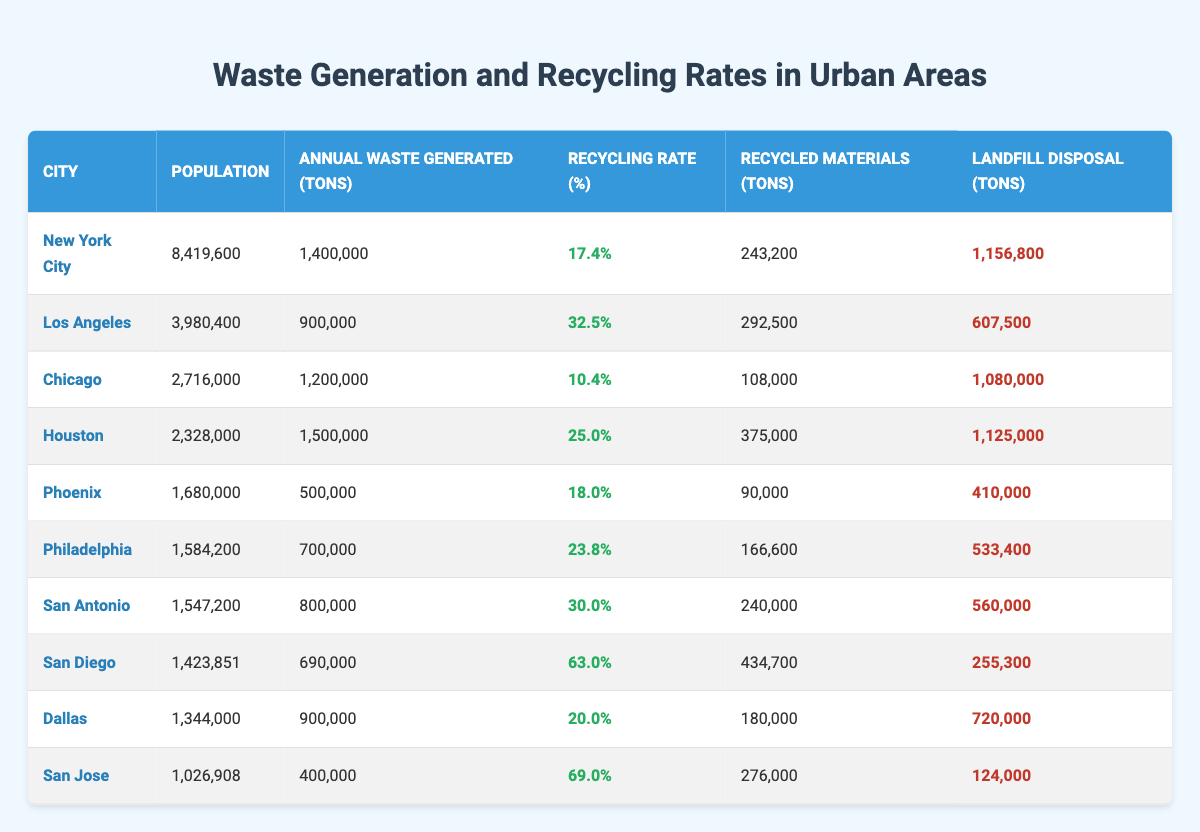What is the recycling rate percentage for Los Angeles? In the table, locate the row for Los Angeles and find the corresponding value under the "Recycling Rate (%)" column. The value is 32.5%.
Answer: 32.5% Which city generated the most annual waste in tons? Reviewing the "Annual Waste Generated (tons)" column, identify the maximum value, which corresponds to New York City with 1,400,000 tons.
Answer: New York City What is the landfill disposal amount for San Diego? Locate the row for San Diego and read the value in the "Landfill Disposal (tons)" column, which is 255,300 tons.
Answer: 255,300 tons What is the average recycling rate percentage of the cities listed? To find the average, sum the recycling rates: 17.4 + 32.5 + 10.4 + 25.0 + 18.0 + 23.8 + 30 + 63 + 20 + 69 =  289.1, then divide by the number of cities (10): 289.1 / 10 = 28.91%.
Answer: 28.91% Which city has the lowest recycling rate? Look through the "Recycling Rate (%)" column to find the minimum value, which is 10.4% from Chicago.
Answer: Chicago What is the total annual waste generated by the cities combined? Sum the values in the "Annual Waste Generated (tons)" column: 1,400,000 + 900,000 + 1,200,000 + 1,500,000 + 500,000 + 700,000 + 800,000 + 690,000 + 900,000 + 400,000 = 8,690,000 tons.
Answer: 8,690,000 tons Does Philadelphia have a higher recycling rate than Chicago? Compare the recycling rates: Philadelphia's is 23.8% and Chicago's is 10.4%. Since 23.8% is greater than 10.4%, the answer is yes.
Answer: Yes What percentage of the waste generated in San Jose is recycled? For San Jose, the recycling rate is given as 69%, meaning 69% of the annual waste generated of 400,000 tons is recycled.
Answer: 69% If Houston's landfill disposal is reduced by 100,000 tons, what would be the new amount? Start with Houston's landfill disposal amount of 1,125,000 tons and subtract 100,000 tons: 1,125,000 - 100,000 = 1,025,000 tons.
Answer: 1,025,000 tons What is the difference in the total landfill disposal between San Antonio and Dallas? Find the landfill disposal for San Antonio (560,000 tons) and Dallas (720,000 tons), then calculate the difference: 720,000 - 560,000 = 160,000 tons.
Answer: 160,000 tons Which city has more landfill disposal, Philadelphia or Phoenix? Check the landfill disposal for Philadelphia which is 533,400 tons and for Phoenix which is 410,000 tons. Since 533,400 is greater than 410,000, Philadelphia has more landfill disposal.
Answer: Philadelphia 